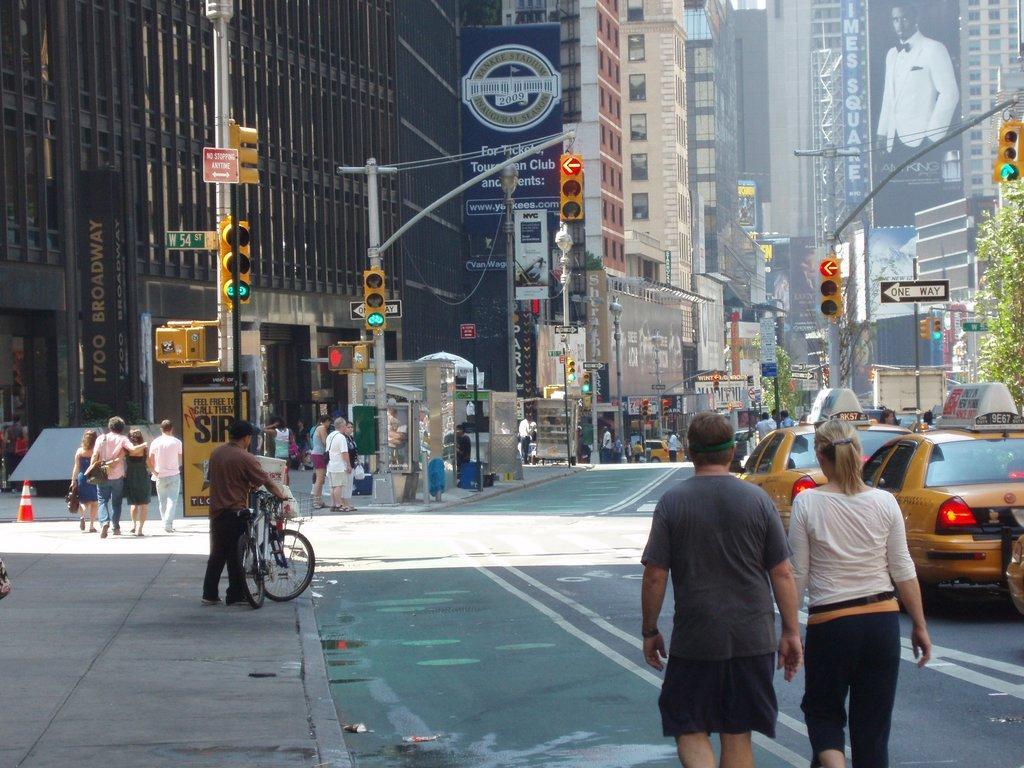In one or two sentences, can you explain what this image depicts? This picture is taken in the streets of a city. The foreground of the image there are two persons walking. On the left there is a pavement, on the pavement there are a lot of people walking. On the background there are many buildings. On the right there are cars. In this image there are many signals. On the right there is a tree. 